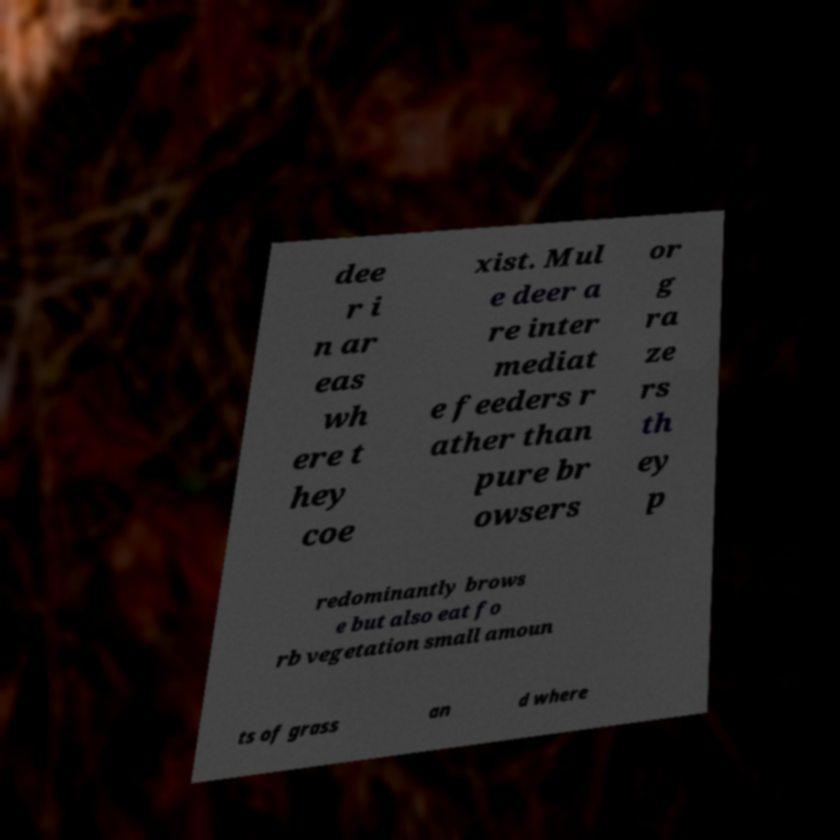Could you assist in decoding the text presented in this image and type it out clearly? dee r i n ar eas wh ere t hey coe xist. Mul e deer a re inter mediat e feeders r ather than pure br owsers or g ra ze rs th ey p redominantly brows e but also eat fo rb vegetation small amoun ts of grass an d where 